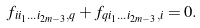Convert formula to latex. <formula><loc_0><loc_0><loc_500><loc_500>f _ { i i _ { 1 } \dots i _ { 2 m - 3 } , q } + f _ { q i _ { 1 } \dots i _ { 2 m - 3 } , i } = 0 .</formula> 